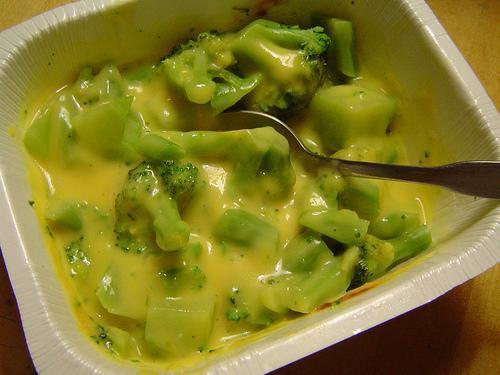How many pieces of broccoli surround the spoon?
Give a very brief answer. 3. 